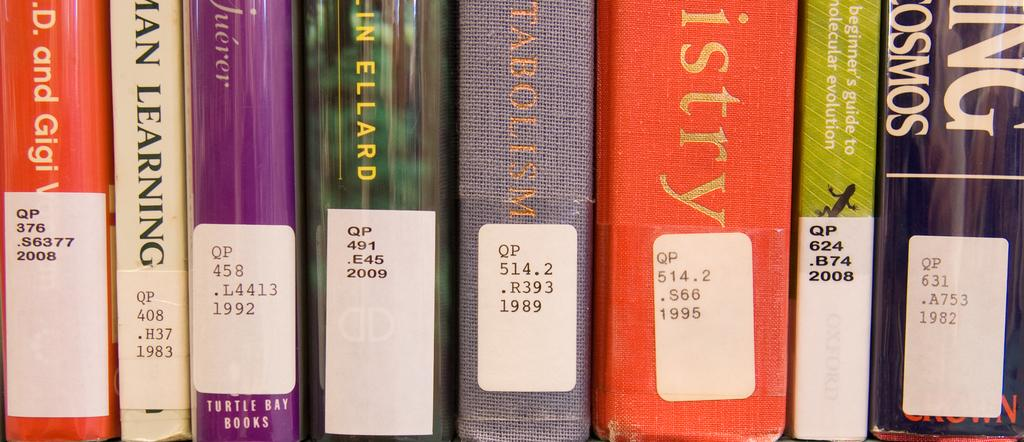<image>
Share a concise interpretation of the image provided. Several books standing up, the first one's sticker reads QP376.S63772008 